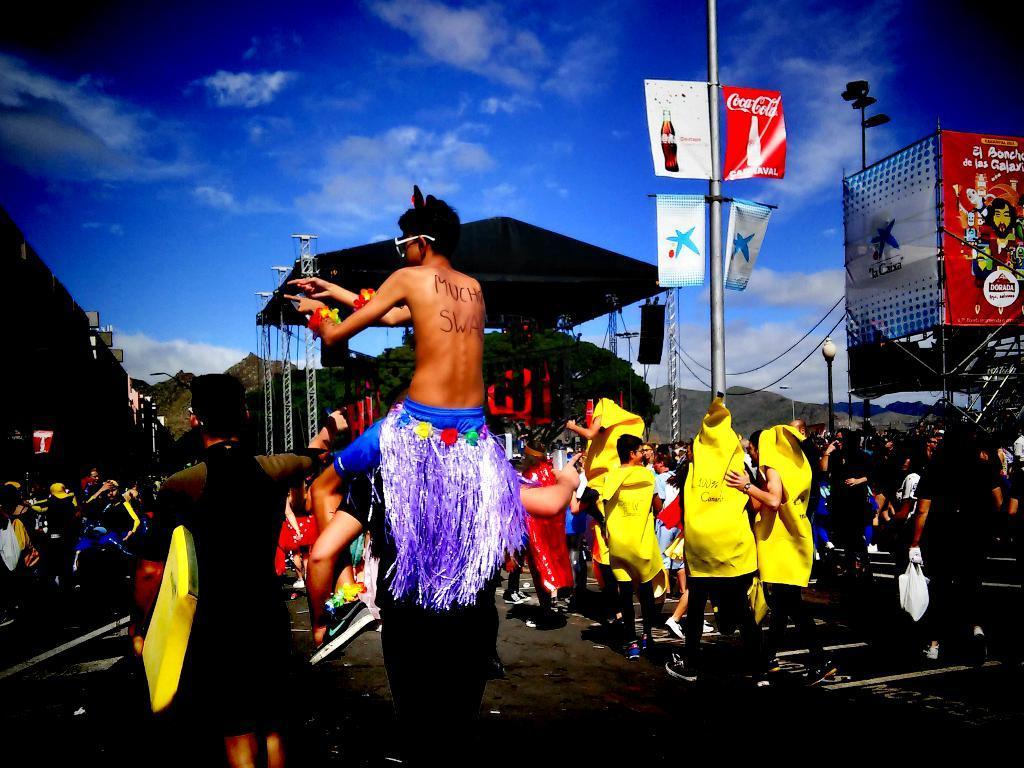Could you give a brief overview of what you see in this image? In this picture I can see three person's, a person holding an object , a person in a fancy dress is on another person, and in the background there are group of people standing, there are lights, poles, lighting trusses, boards or banners , trees and there is sky. 